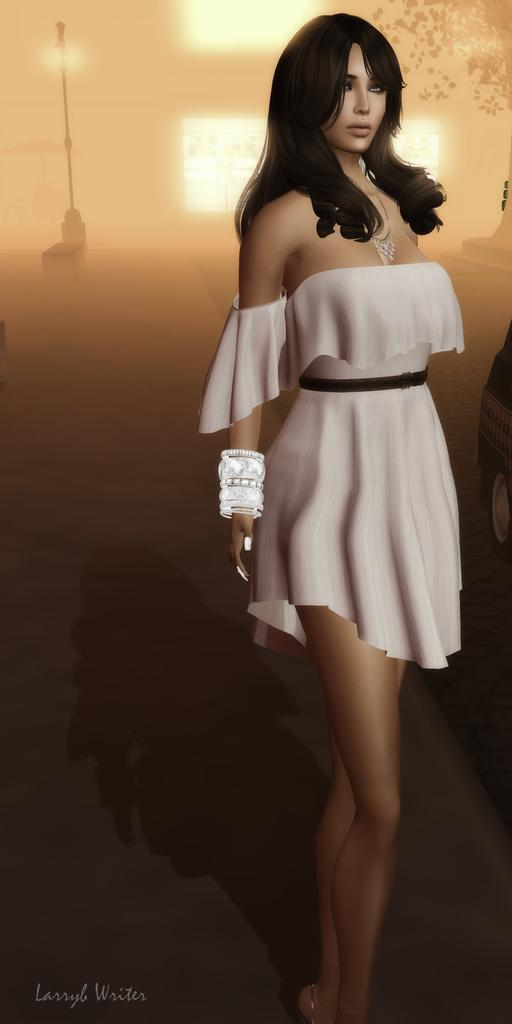What type of image is being described? The image is an animation. What is the woman in the image doing? The woman is standing on the road. What objects can be seen on the road in the image? There is a street pole and a street light in the image. What type of vehicle is present in the image? There is a motor vehicle in the image. Where is the company located in the image? There is no company present in the image; it features an animation of a woman standing on the road with a street pole, a street light, and a motor vehicle. 